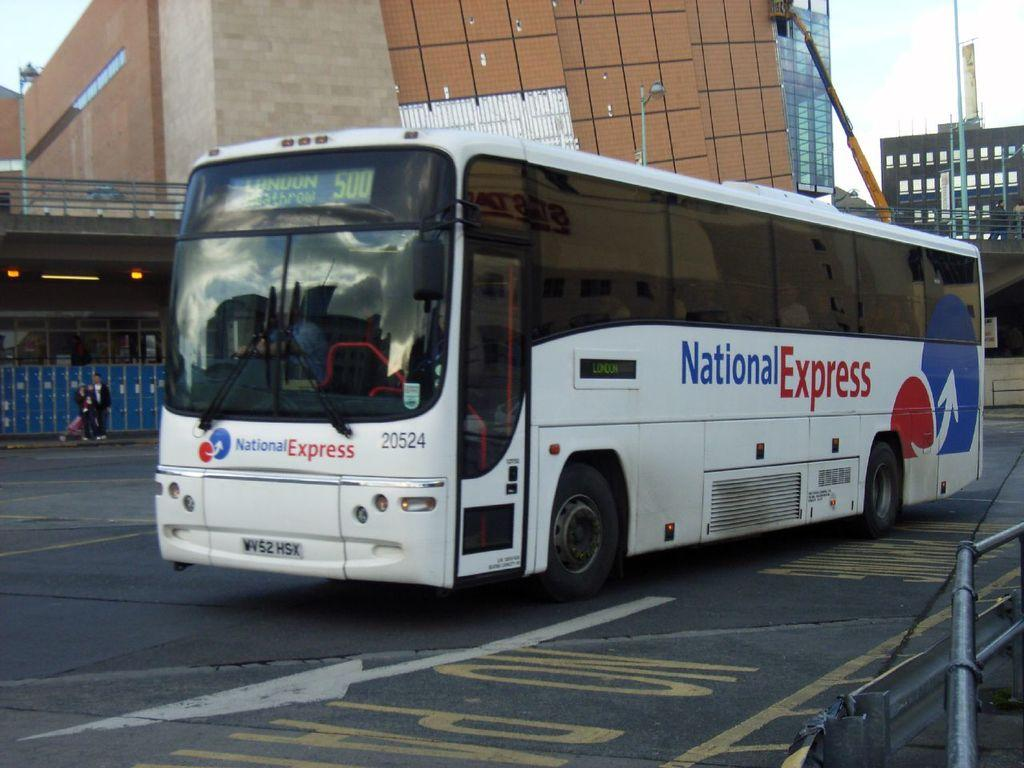Provide a one-sentence caption for the provided image. A National Express bus that is driving to London. 